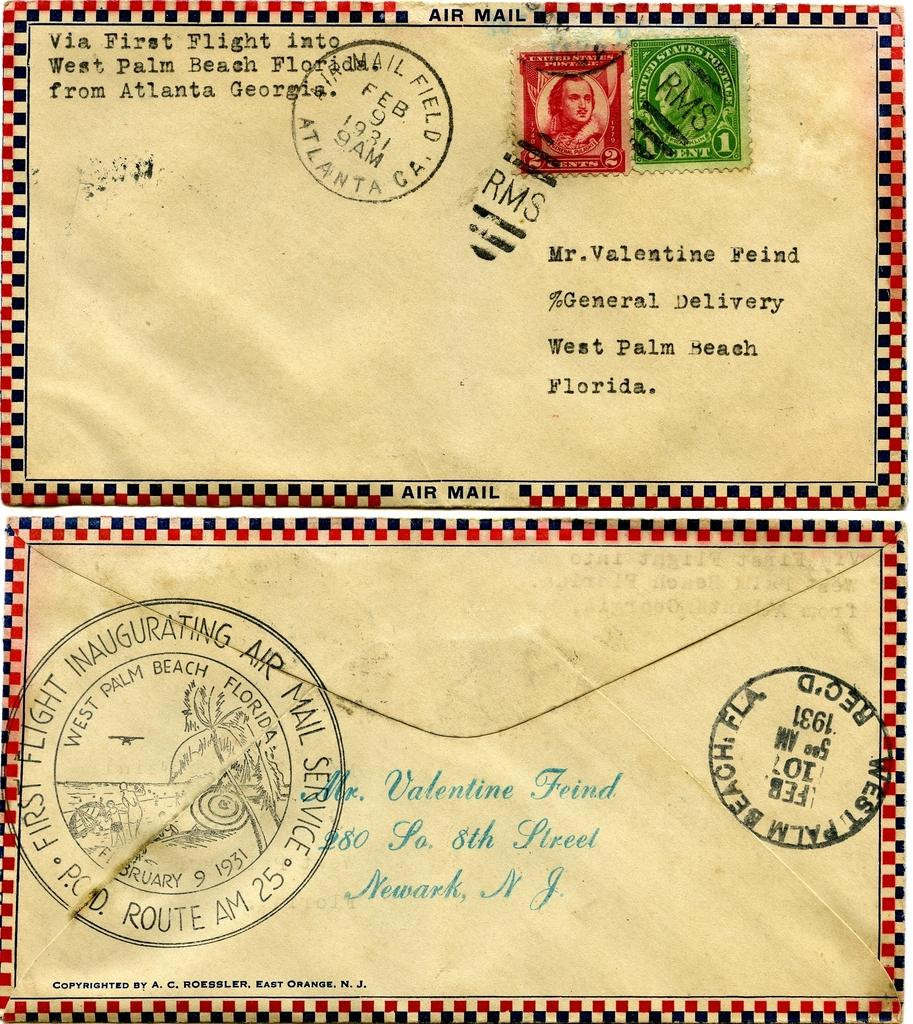<image>
Create a compact narrative representing the image presented. An air mail letter intended for a Mr. Valentine Feind in West Palm Beach, Florida. 